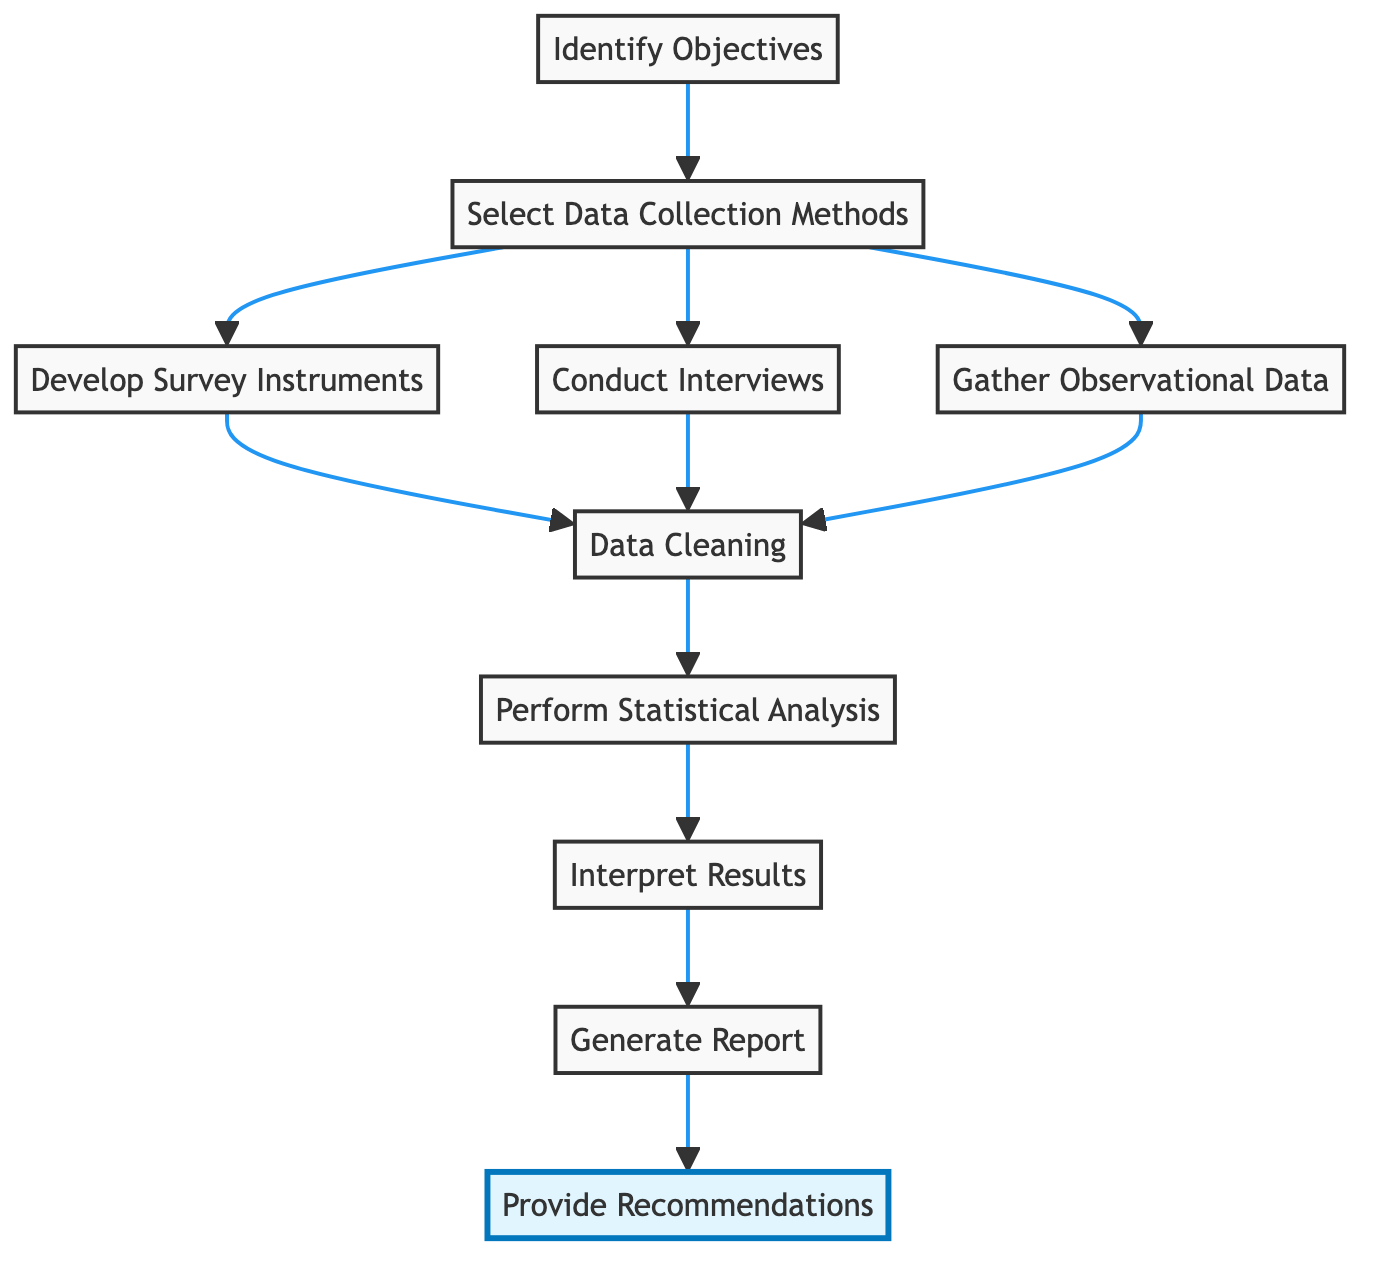What is the first step in the flowchart? The first step in the flowchart is "Identify Objectives," which defines the key metrics and objectives for team performance enhancement.
Answer: Identify Objectives How many distinct data collection methods are selected in the flowchart? The flowchart lists three distinct data collection methods: "Develop Survey Instruments," "Conduct Interviews," and "Gather Observational Data."
Answer: Three What comes after "Data Cleaning"? After "Data Cleaning," the next step is "Perform Statistical Analysis," which involves using statistical methods to analyze the cleaned data.
Answer: Perform Statistical Analysis Which step directly precedes "Provide Recommendations"? The step that directly precedes "Provide Recommendations" is "Generate Report," where the results and insights are compiled into a comprehensive report.
Answer: Generate Report What are the three methods of data collection shown in the diagram? The three methods of data collection are "Develop Survey Instruments," "Conduct Interviews," and "Gather Observational Data," as chosen after selecting the data collection methods.
Answer: Develop Survey Instruments, Conduct Interviews, Gather Observational Data What is the last step in the flowchart? The last step in the flowchart is "Provide Recommendations," where evidence-based recommendations to improve team performance and work culture are offered.
Answer: Provide Recommendations How does "Interpret Results" relate to "Perform Statistical Analysis"? "Interpret Results" comes after "Perform Statistical Analysis," indicating that insights are drawn from the analyzed data which allows for understanding team performance.
Answer: It follows after What step involves creating surveys and questionnaires? The step that involves creating surveys and questionnaires is "Develop Survey Instruments," which aims to gather qualitative and quantitative data.
Answer: Develop Survey Instruments Which element is represented by the node labeled 'F' in the flowchart? The node labeled 'F' represents "Data Cleaning," which is the process of cleaning the collected data to remove any inconsistencies or errors.
Answer: Data Cleaning 